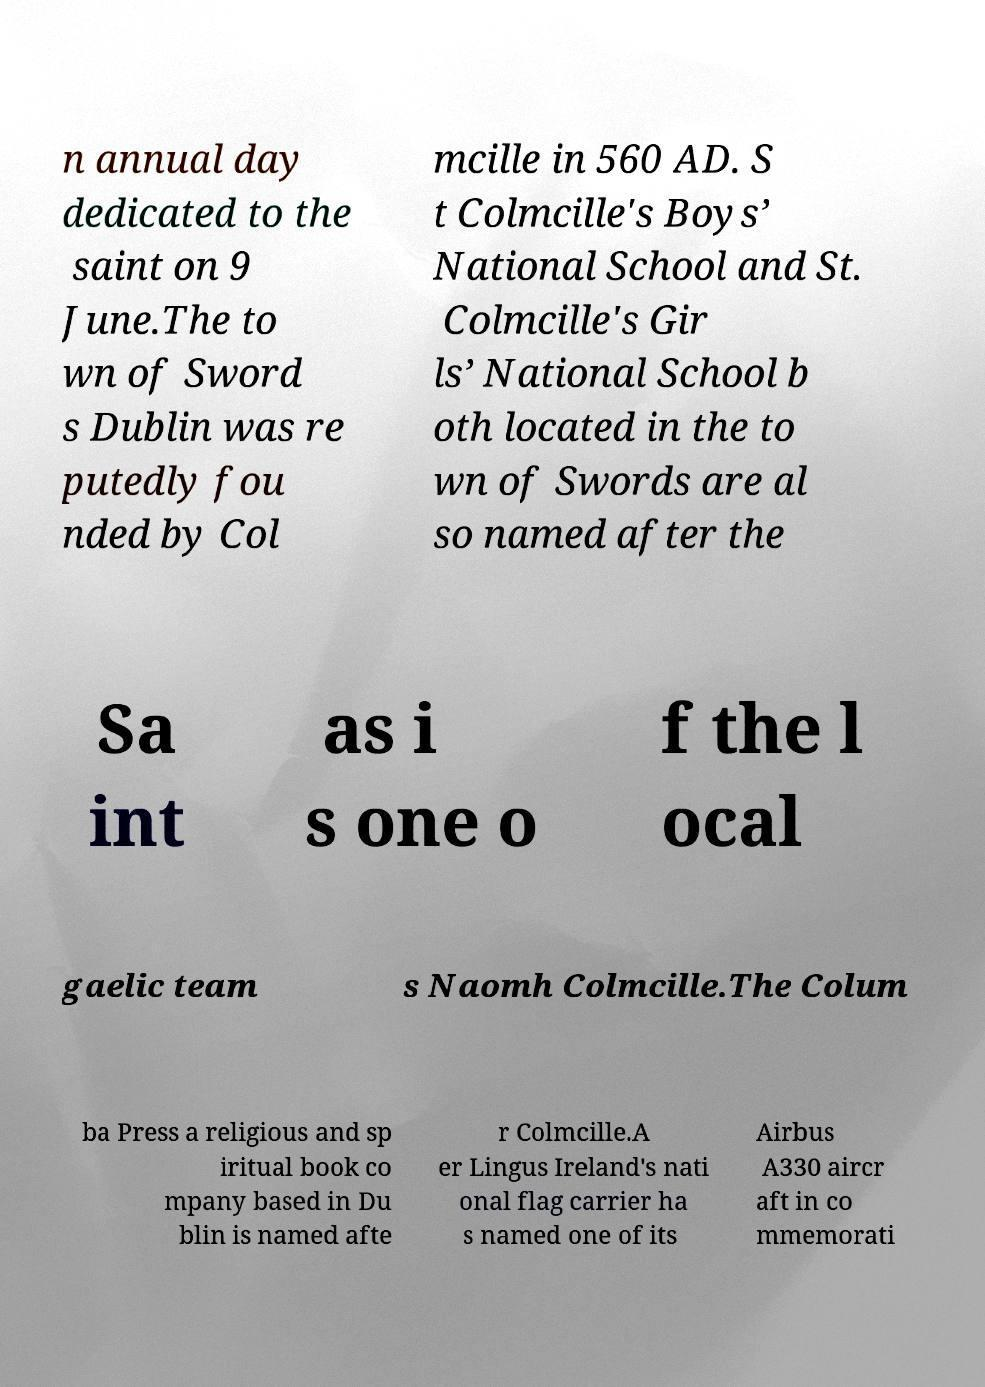What messages or text are displayed in this image? I need them in a readable, typed format. n annual day dedicated to the saint on 9 June.The to wn of Sword s Dublin was re putedly fou nded by Col mcille in 560 AD. S t Colmcille's Boys’ National School and St. Colmcille's Gir ls’ National School b oth located in the to wn of Swords are al so named after the Sa int as i s one o f the l ocal gaelic team s Naomh Colmcille.The Colum ba Press a religious and sp iritual book co mpany based in Du blin is named afte r Colmcille.A er Lingus Ireland's nati onal flag carrier ha s named one of its Airbus A330 aircr aft in co mmemorati 